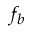Convert formula to latex. <formula><loc_0><loc_0><loc_500><loc_500>f _ { b }</formula> 